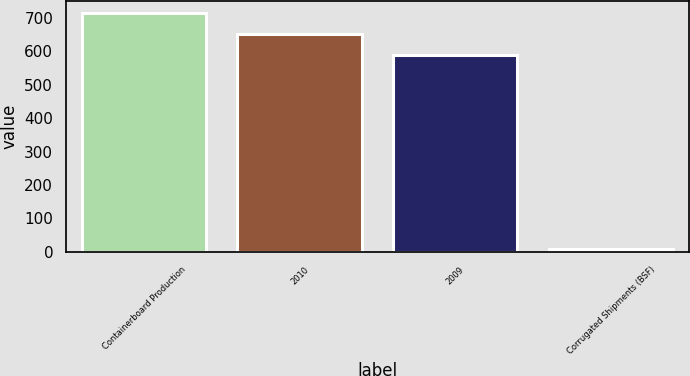Convert chart. <chart><loc_0><loc_0><loc_500><loc_500><bar_chart><fcel>Containerboard Production<fcel>2010<fcel>2009<fcel>Corrugated Shipments (BSF)<nl><fcel>716.34<fcel>652.17<fcel>588<fcel>8.3<nl></chart> 